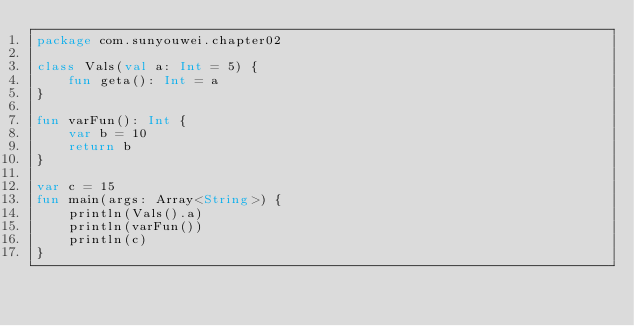Convert code to text. <code><loc_0><loc_0><loc_500><loc_500><_Kotlin_>package com.sunyouwei.chapter02

class Vals(val a: Int = 5) {
    fun geta(): Int = a
}

fun varFun(): Int {
    var b = 10
    return b
}

var c = 15
fun main(args: Array<String>) {
    println(Vals().a)
    println(varFun())
    println(c)
}</code> 